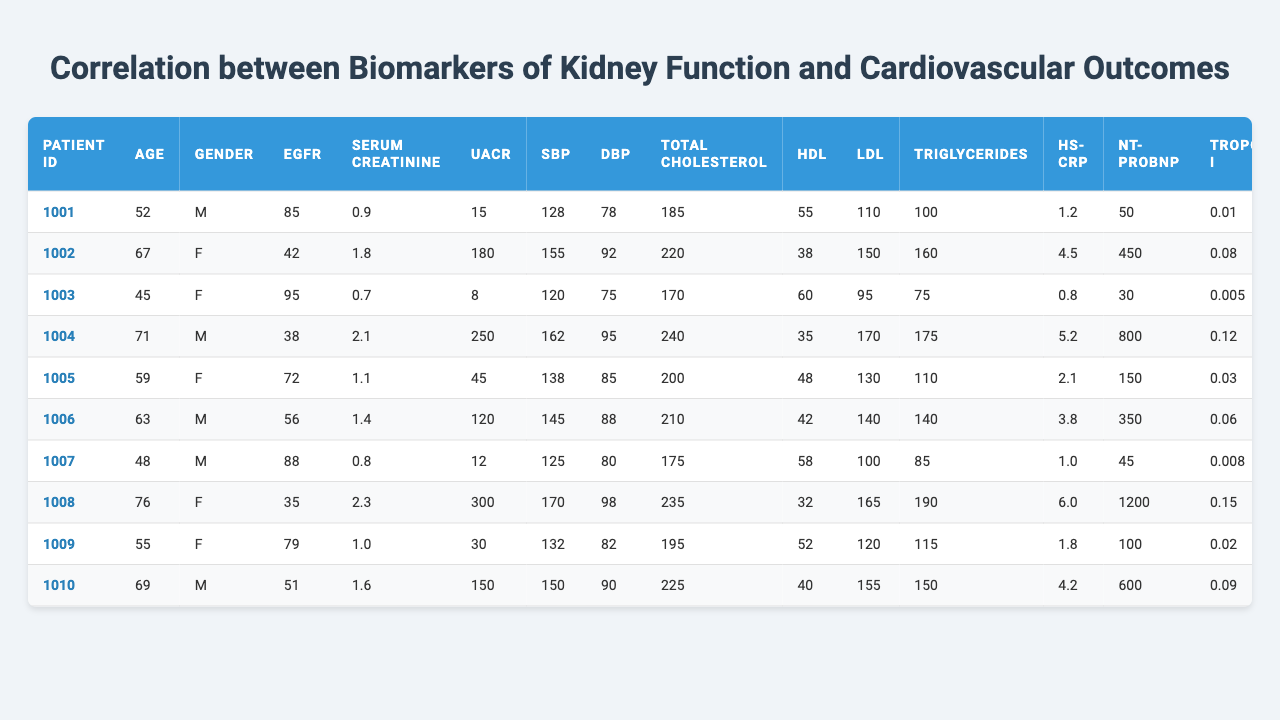What is the eGFR value for Patient ID 1004? The eGFR value is listed in the table under the column "eGFR" corresponding to Patient ID 1004. Looking at that row, the value is 38.
Answer: 38 What is the serum creatinine level of the patient with the highest HDL cholesterol? We need to find the maximum HDL cholesterol value in the "HDL" column. The highest value is 60, which belongs to Patient ID 1003. Looking at the same row in the "Serum Creatinine" column, the value is 0.7.
Answer: 0.7 How many patients have a history of cardiovascular disease (CVD)? We look at the "CVD History" column and count the number of entries marked as true. There are 5 patients with a history of CVD.
Answer: 5 What is the average age of patients with a history of diabetes? Start by identifying patients with a true diabetes history in the "Diabetes History" column. The corresponding ages are 67, 71, 59, 76, and 69. The average is calculated as (67 + 71 + 59 + 76 + 69) / 5 = 68.4.
Answer: 68.4 Which patient has the highest NT-proBNP value? We check the "NT-proBNP" column to determine which row has the maximum value and find that Patient ID 1008 has the highest value of 1200.
Answer: Patient ID 1008 What is the relationship between serum creatinine and cardiovascular events in this cohort? We'll compare the "Serum Creatinine" values with the "CV Event (5yr)" column. Patients who had a cardiovascular event (true) have varied creatinine levels, but notable is Patient ID 1002 with a high level of 1.8 and having a cardiovascular event. In contrast, there are also patients with lower creatinine levels who did not have events.
Answer: Varies, but high creatinine is associated with events Is there a patient who never smoked and has a high eGFR? We look at the "Smoking Status" column and find the patients who are marked as "Never." Among them, the highest eGFR is that of Patient ID 1007 at 88.
Answer: Yes, Patient ID 1007 How many patients have both high systolic blood pressure (>140) and a history of diabetes? First, identify patients with systolic blood pressure greater than 140 from the "SBP" column: Patients 1002, 1004, 1006, 1008, and 1010. Next, check their diabetes history and find that 1002, 1004, and 1008 have diabetes. Thus, there are 3 patients in total.
Answer: 3 What factors might contribute to the cardiovascular events in patients with low eGFR? Looking at patients with low eGFR (less than 60), we assess their serum creatinine, hs-CRP, and NT-proBNP values. Noteworthy is that high hs-CRP and NT-proBNP are present in patients with low eGFR and notable cardiovascular events, indicating a potential link.
Answer: Elevated hs-CRP and NT-proBNP are factors What is the median age of patients who have experienced a cardiovascular event? Identify the ages of patients who have had a cardiovascular event (true): 67, 71, 63, 76, and 69. Arranging them gives us: 63, 67, 69, 71, 76. The median is the middle value, which is 69.
Answer: 69 